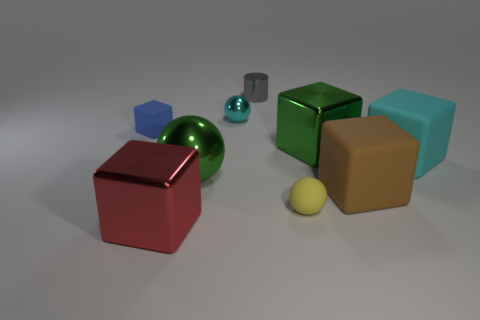There is a cube that is the same color as the tiny metal ball; what is its material?
Give a very brief answer. Rubber. What size is the object that is on the left side of the gray cylinder and in front of the large brown rubber object?
Provide a short and direct response. Large. What number of other things are there of the same shape as the gray object?
Give a very brief answer. 0. Is the shape of the yellow rubber object the same as the cyan thing that is behind the large cyan thing?
Provide a succinct answer. Yes. There is a red metal object; how many cyan metal balls are in front of it?
Ensure brevity in your answer.  0. Does the cyan thing in front of the blue rubber cube have the same shape as the red object?
Ensure brevity in your answer.  Yes. The large metallic block on the right side of the tiny yellow ball is what color?
Your answer should be very brief. Green. There is a small yellow thing that is made of the same material as the small block; what is its shape?
Your response must be concise. Sphere. Is there any other thing that is the same color as the big metallic ball?
Your answer should be compact. Yes. Is the number of green objects that are right of the tiny yellow sphere greater than the number of big spheres that are to the right of the brown thing?
Ensure brevity in your answer.  Yes. 